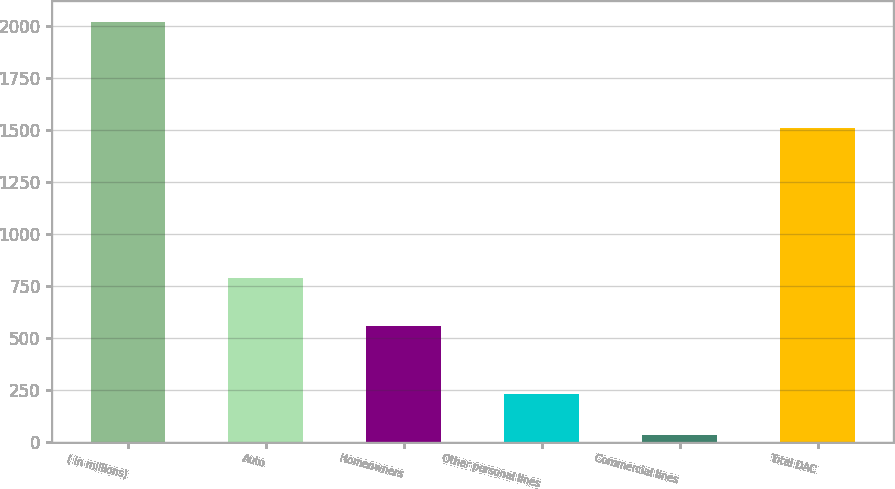Convert chart to OTSL. <chart><loc_0><loc_0><loc_500><loc_500><bar_chart><fcel>( in millions)<fcel>Auto<fcel>Homeowners<fcel>Other personal lines<fcel>Commercial lines<fcel>Total DAC<nl><fcel>2017<fcel>789<fcel>558<fcel>229.6<fcel>31<fcel>1510<nl></chart> 